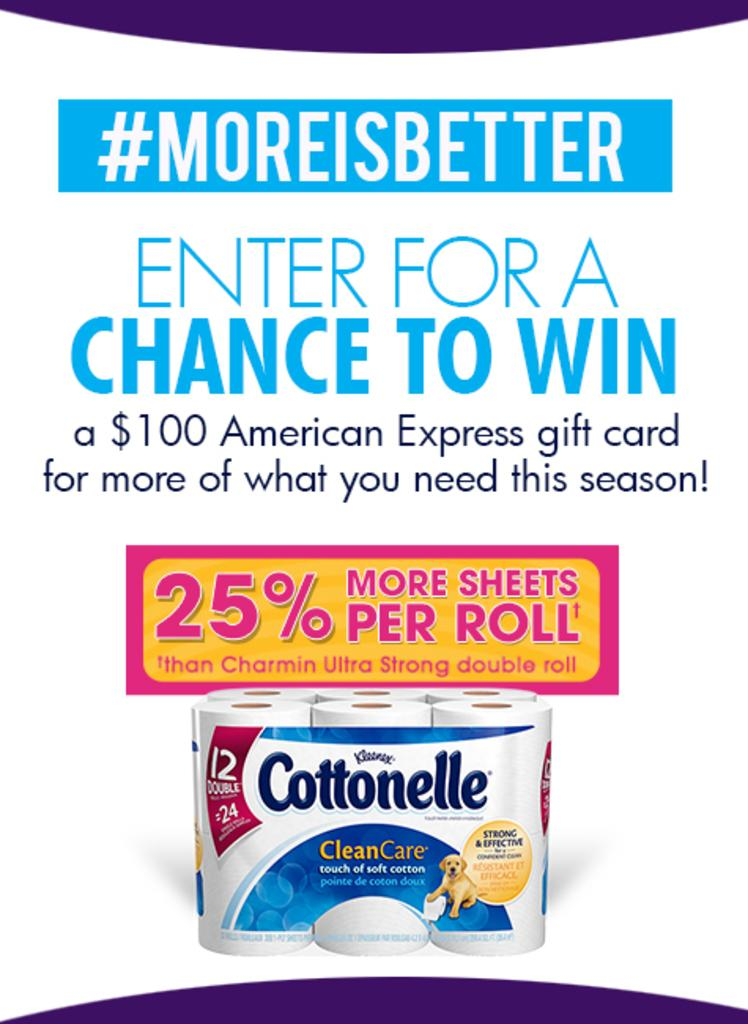What is featured on the poster in the image? There is a poster in the image, and it has a picture of napkins. What else can be seen on the poster besides the picture of napkins? There is text on the poster. Can you tell me how many bees are buzzing around the poster in the image? There are no bees present in the image; it only features a poster with a picture of napkins and text. What type of war is depicted on the poster in the image? There is no war depicted on the poster in the image; it only features a picture of napkins and text. 